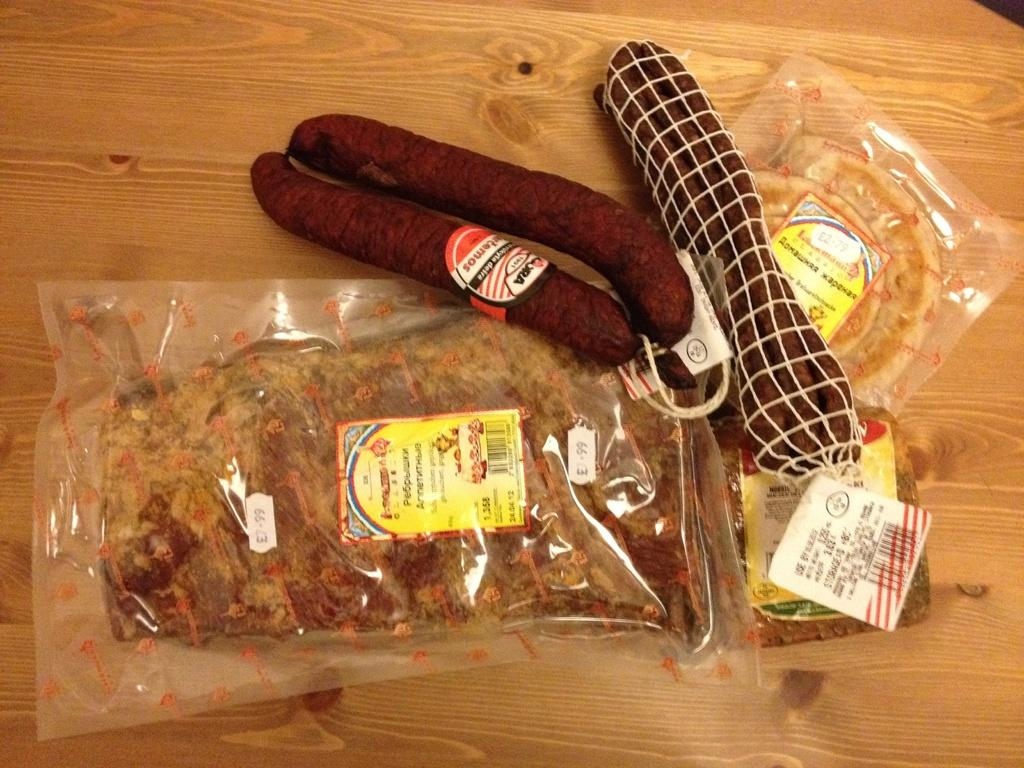What type of food can be seen in the image? There are sausages in the image. What else is present in the image besides sausages? There are food packets and covers visible in the image. Where are the items located in the image? The items are kept on a table. In which setting is the image taken? The image is taken in a room. What type of trousers are being worn by the sausages in the image? There are no trousers or people present in the image, as it features sausages, food packets, and covers on a table. 